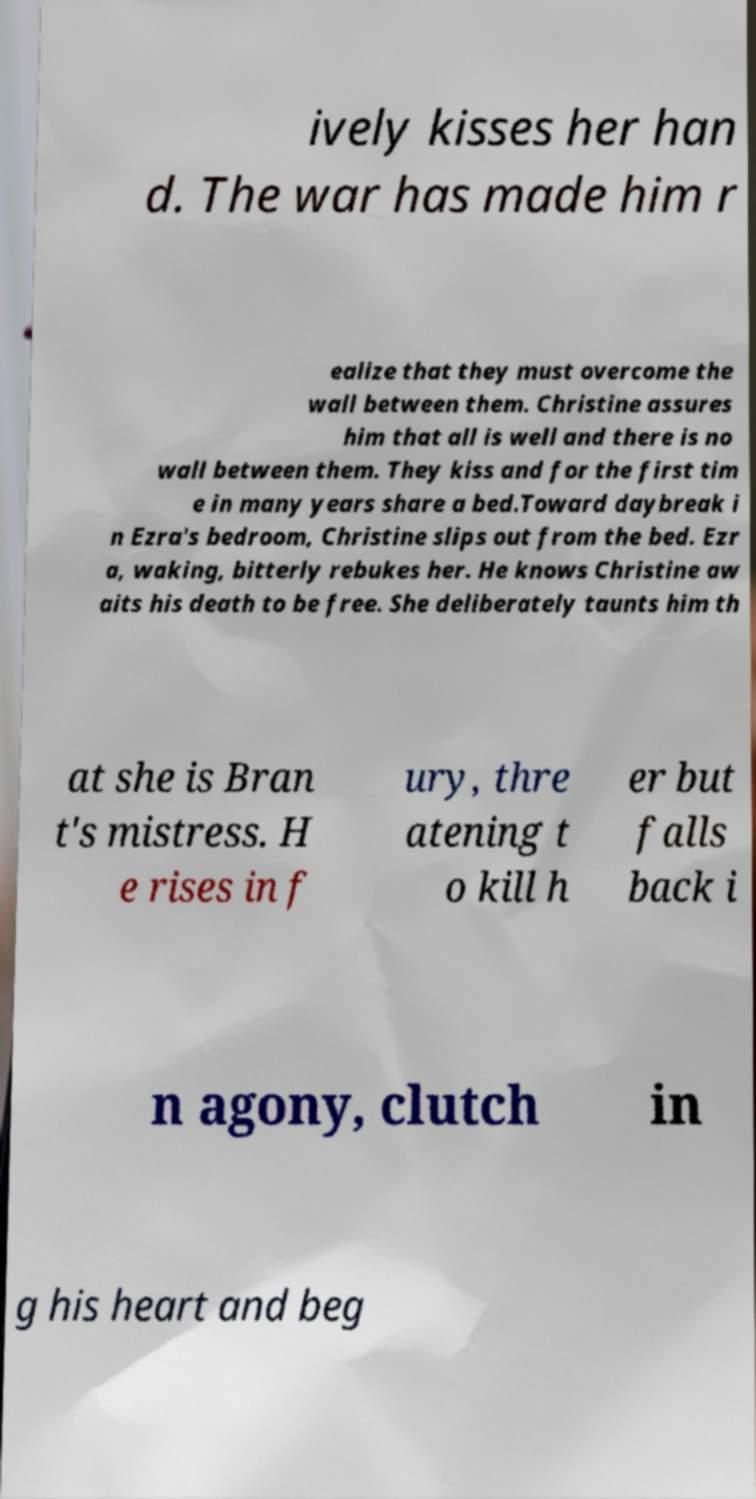What messages or text are displayed in this image? I need them in a readable, typed format. ively kisses her han d. The war has made him r ealize that they must overcome the wall between them. Christine assures him that all is well and there is no wall between them. They kiss and for the first tim e in many years share a bed.Toward daybreak i n Ezra's bedroom, Christine slips out from the bed. Ezr a, waking, bitterly rebukes her. He knows Christine aw aits his death to be free. She deliberately taunts him th at she is Bran t's mistress. H e rises in f ury, thre atening t o kill h er but falls back i n agony, clutch in g his heart and beg 